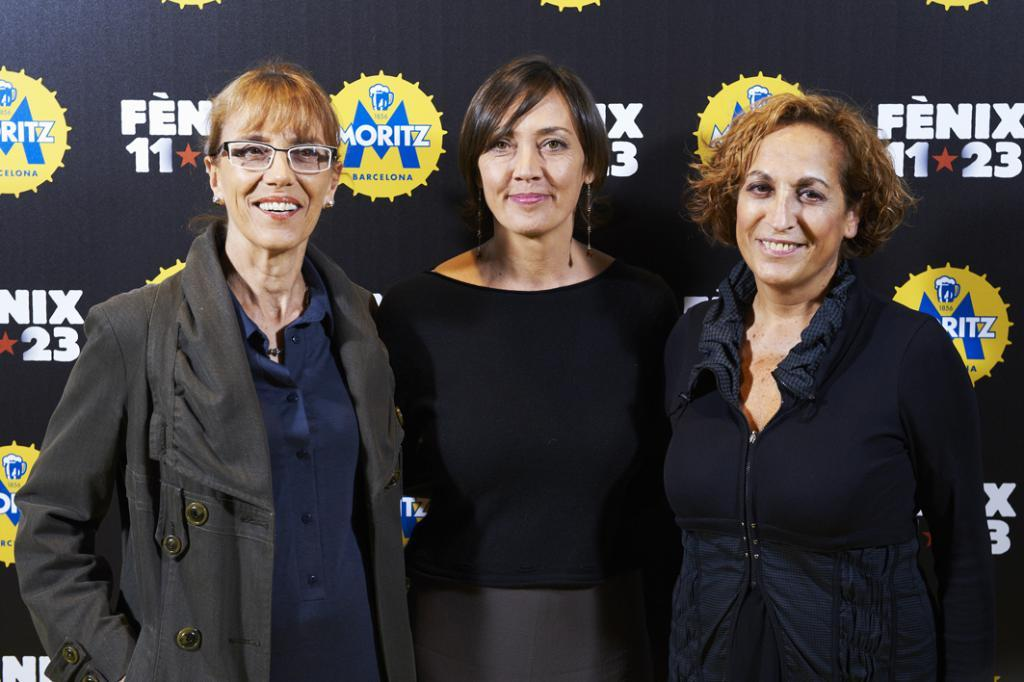How many people are in the image? There are three ladies in the image. What are the ladies doing in the image? The ladies are standing and smiling. What can be seen in the background of the image? There is a board in the background of the image. What is the lady on the left wearing? The lady standing on the left is wearing a jacket. Who is the creator of the punishment depicted in the image? There is no punishment depicted in the image; it features three ladies standing and smiling. What type of bucket can be seen in the image? There is no bucket present in the image. 